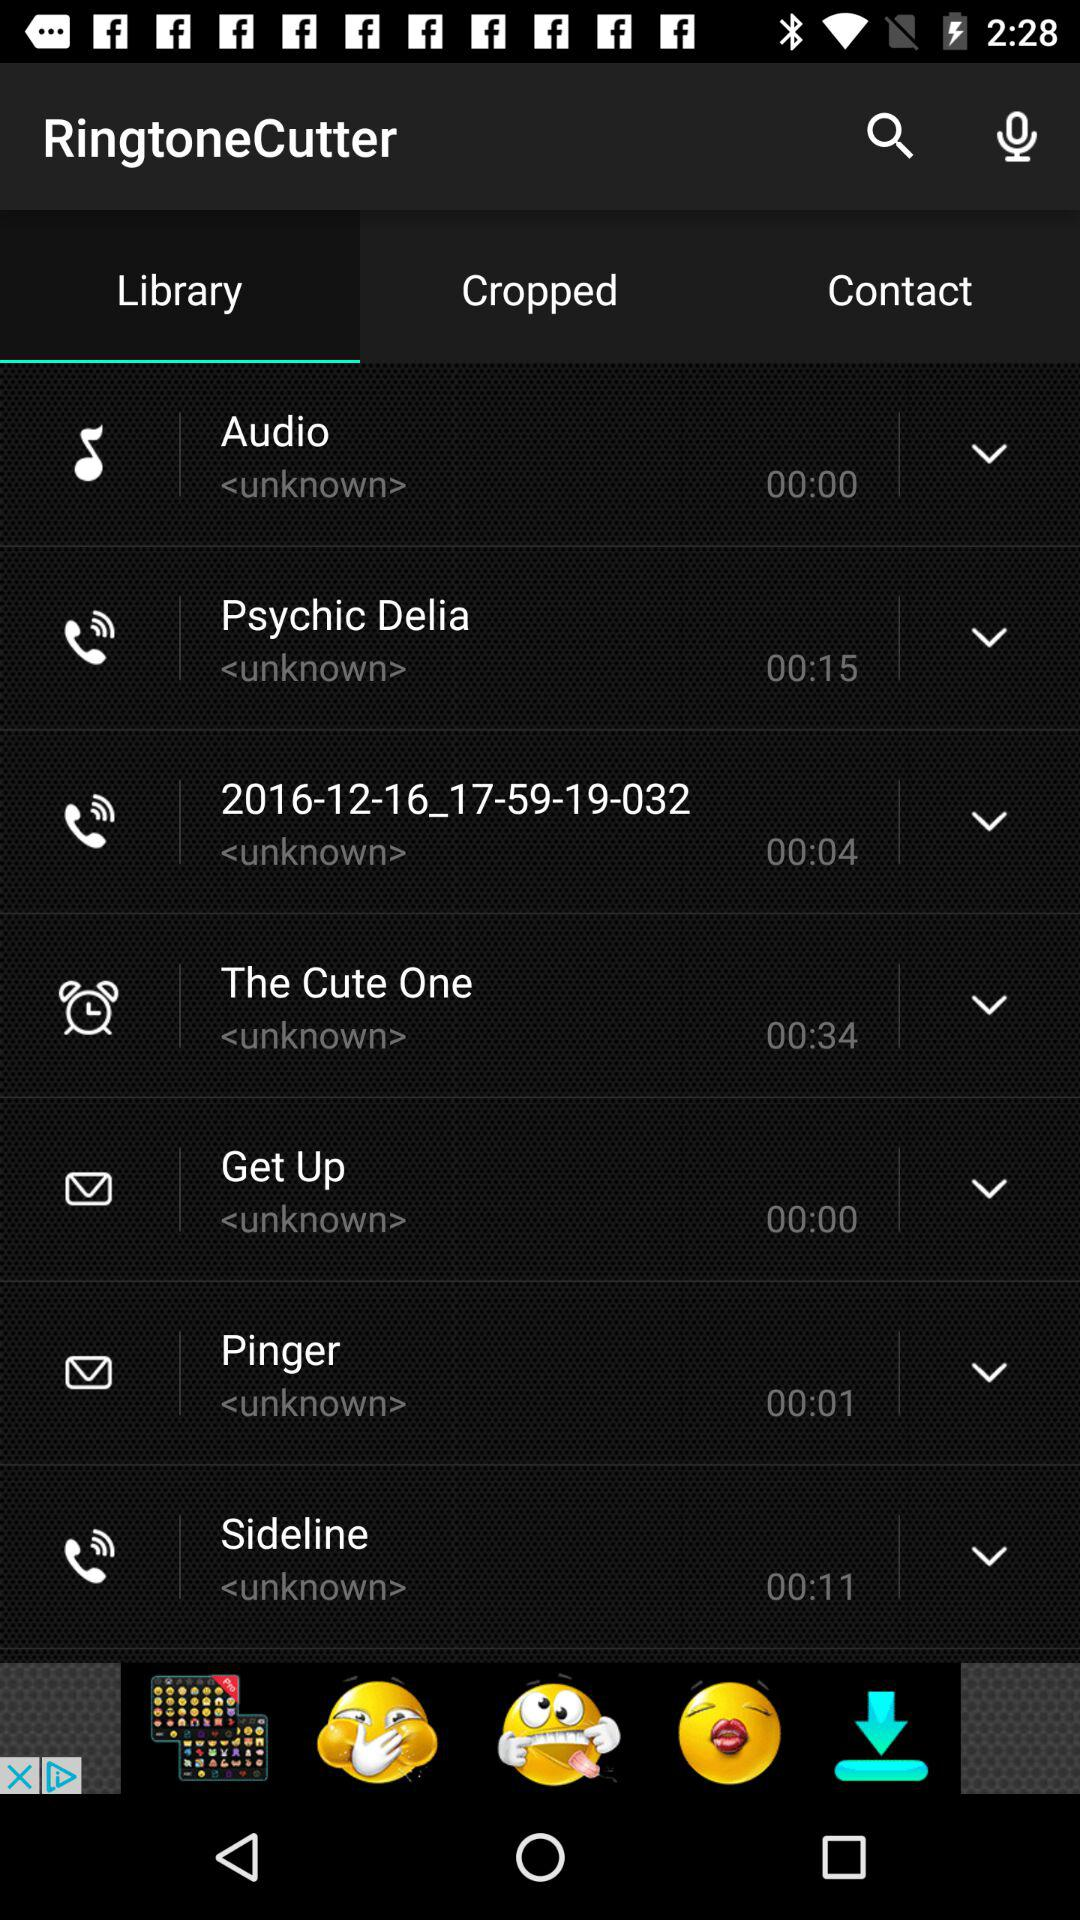How many seconds are in the longest audio file?
Answer the question using a single word or phrase. 00:34 